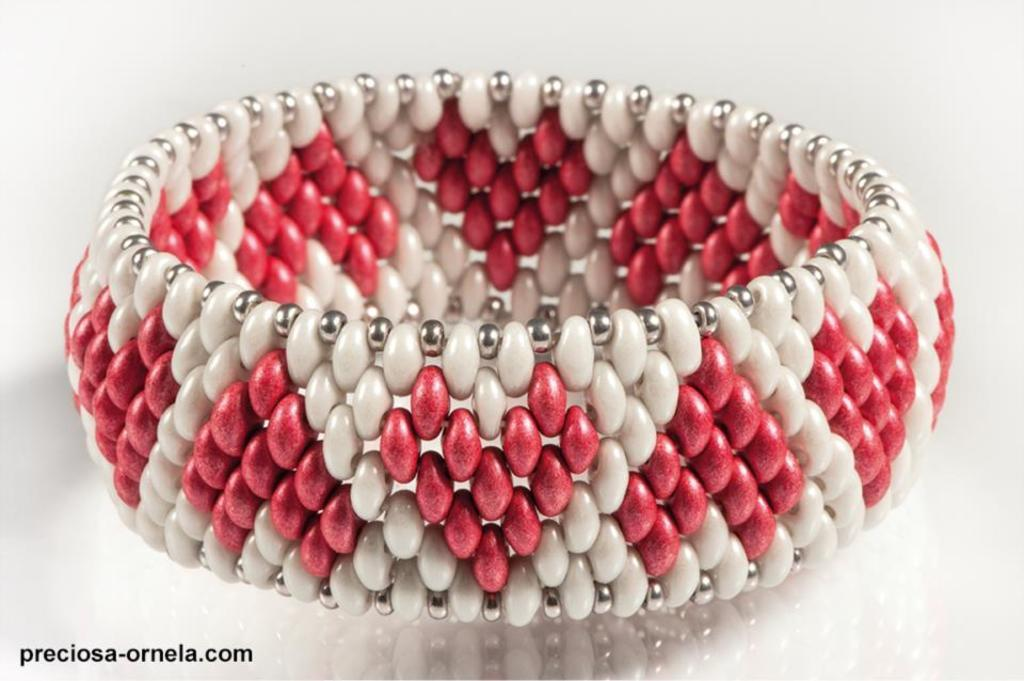What type of jewelry is in the image? There is a bangle in the image. What colors can be seen on the bangle? The bangle has white, red, and silver colors. What is the bangle placed on in the image? The bangle is on a white surface. Is there any additional mark or feature in the image? Yes, there is a watermark in the image. Can you tell me how many corn cobs are on the bangle in the image? There are no corn cobs present on the bangle in the image; it only has white, red, and silver colors. Is there a library visible in the image? There is no library present in the image; it only features a bangle on a white surface. 